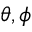Convert formula to latex. <formula><loc_0><loc_0><loc_500><loc_500>\theta , \phi</formula> 